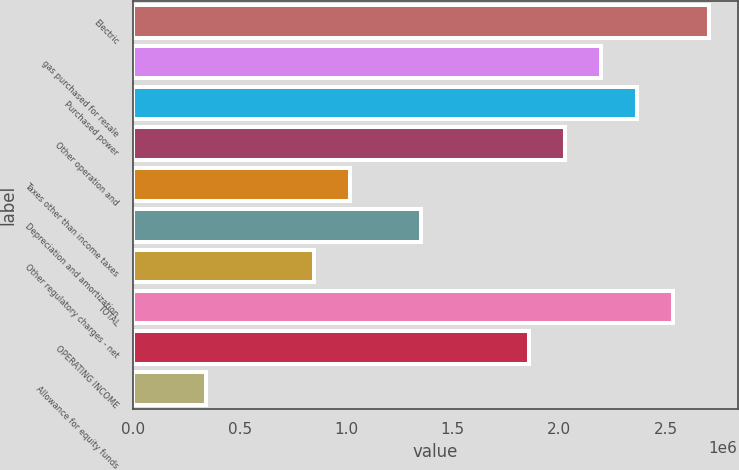<chart> <loc_0><loc_0><loc_500><loc_500><bar_chart><fcel>Electric<fcel>gas purchased for resale<fcel>Purchased power<fcel>Other operation and<fcel>Taxes other than income taxes<fcel>Depreciation and amortization<fcel>Other regulatory charges - net<fcel>TOTAL<fcel>OPERATING INCOME<fcel>Allowance for equity funds<nl><fcel>2.70276e+06<fcel>2.19659e+06<fcel>2.36532e+06<fcel>2.02787e+06<fcel>1.01555e+06<fcel>1.35299e+06<fcel>846826<fcel>2.53404e+06<fcel>1.85915e+06<fcel>340662<nl></chart> 